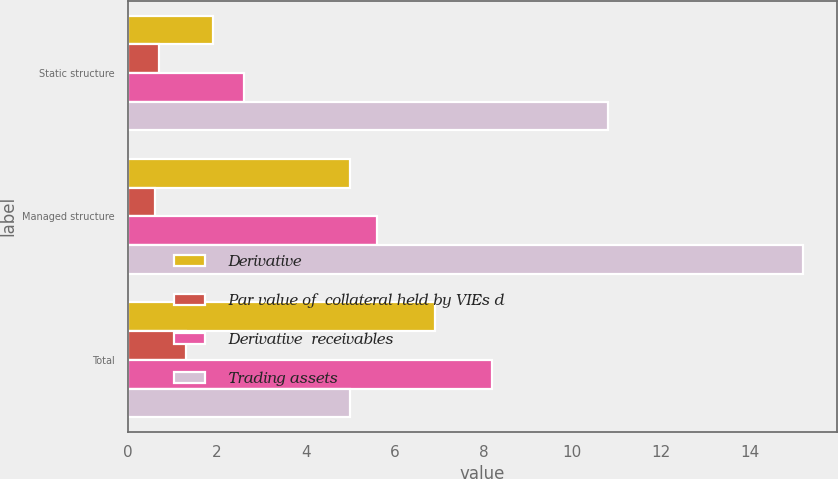Convert chart. <chart><loc_0><loc_0><loc_500><loc_500><stacked_bar_chart><ecel><fcel>Static structure<fcel>Managed structure<fcel>Total<nl><fcel>Derivative<fcel>1.9<fcel>5<fcel>6.9<nl><fcel>Par value of  collateral held by VIEs d<fcel>0.7<fcel>0.6<fcel>1.3<nl><fcel>Derivative  receivables<fcel>2.6<fcel>5.6<fcel>8.2<nl><fcel>Trading assets<fcel>10.8<fcel>15.2<fcel>5<nl></chart> 